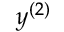Convert formula to latex. <formula><loc_0><loc_0><loc_500><loc_500>y ^ { ( 2 ) }</formula> 